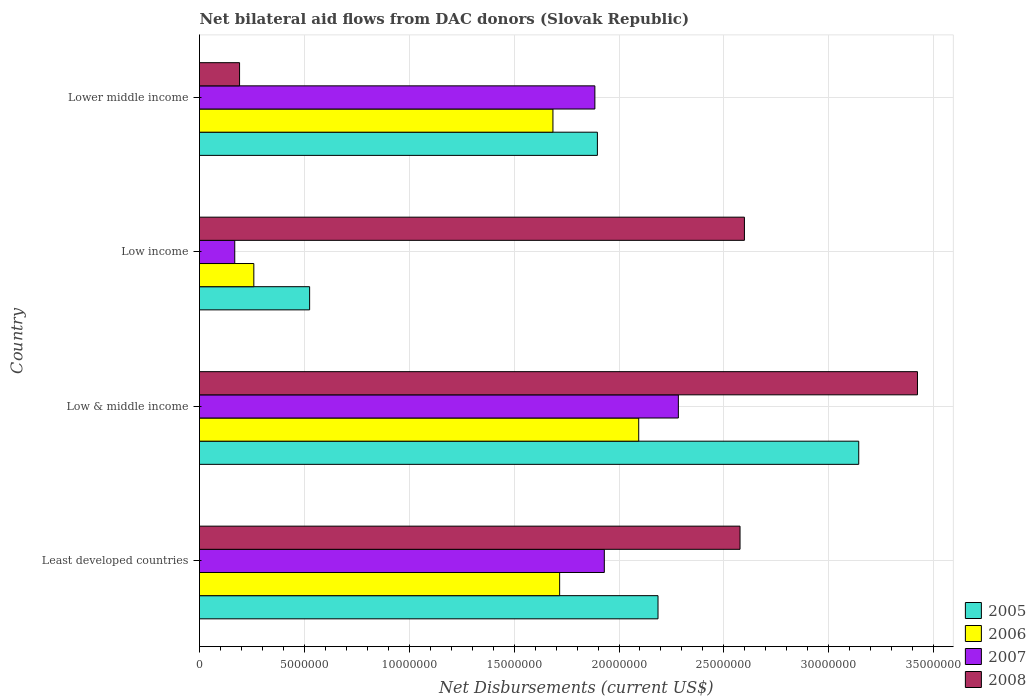How many different coloured bars are there?
Your answer should be very brief. 4. How many groups of bars are there?
Give a very brief answer. 4. Are the number of bars per tick equal to the number of legend labels?
Offer a terse response. Yes. Are the number of bars on each tick of the Y-axis equal?
Provide a short and direct response. Yes. How many bars are there on the 1st tick from the top?
Provide a short and direct response. 4. What is the label of the 1st group of bars from the top?
Provide a short and direct response. Lower middle income. What is the net bilateral aid flows in 2005 in Lower middle income?
Ensure brevity in your answer.  1.90e+07. Across all countries, what is the maximum net bilateral aid flows in 2007?
Your answer should be very brief. 2.28e+07. Across all countries, what is the minimum net bilateral aid flows in 2007?
Ensure brevity in your answer.  1.68e+06. In which country was the net bilateral aid flows in 2006 minimum?
Make the answer very short. Low income. What is the total net bilateral aid flows in 2005 in the graph?
Your response must be concise. 7.75e+07. What is the difference between the net bilateral aid flows in 2007 in Least developed countries and that in Low & middle income?
Ensure brevity in your answer.  -3.53e+06. What is the difference between the net bilateral aid flows in 2007 in Least developed countries and the net bilateral aid flows in 2006 in Low & middle income?
Give a very brief answer. -1.64e+06. What is the average net bilateral aid flows in 2008 per country?
Your response must be concise. 2.20e+07. What is the difference between the net bilateral aid flows in 2008 and net bilateral aid flows in 2005 in Low & middle income?
Your answer should be very brief. 2.80e+06. In how many countries, is the net bilateral aid flows in 2007 greater than 32000000 US$?
Provide a short and direct response. 0. What is the ratio of the net bilateral aid flows in 2005 in Low & middle income to that in Lower middle income?
Give a very brief answer. 1.66. Is the net bilateral aid flows in 2006 in Low income less than that in Lower middle income?
Ensure brevity in your answer.  Yes. What is the difference between the highest and the second highest net bilateral aid flows in 2008?
Offer a terse response. 8.25e+06. What is the difference between the highest and the lowest net bilateral aid flows in 2007?
Offer a very short reply. 2.12e+07. Is it the case that in every country, the sum of the net bilateral aid flows in 2007 and net bilateral aid flows in 2006 is greater than the sum of net bilateral aid flows in 2008 and net bilateral aid flows in 2005?
Your answer should be compact. No. How many bars are there?
Give a very brief answer. 16. How many countries are there in the graph?
Provide a short and direct response. 4. What is the difference between two consecutive major ticks on the X-axis?
Your response must be concise. 5.00e+06. Are the values on the major ticks of X-axis written in scientific E-notation?
Provide a short and direct response. No. How are the legend labels stacked?
Your answer should be compact. Vertical. What is the title of the graph?
Provide a short and direct response. Net bilateral aid flows from DAC donors (Slovak Republic). What is the label or title of the X-axis?
Offer a very short reply. Net Disbursements (current US$). What is the label or title of the Y-axis?
Ensure brevity in your answer.  Country. What is the Net Disbursements (current US$) in 2005 in Least developed countries?
Give a very brief answer. 2.19e+07. What is the Net Disbursements (current US$) in 2006 in Least developed countries?
Give a very brief answer. 1.72e+07. What is the Net Disbursements (current US$) in 2007 in Least developed countries?
Your answer should be compact. 1.93e+07. What is the Net Disbursements (current US$) of 2008 in Least developed countries?
Keep it short and to the point. 2.58e+07. What is the Net Disbursements (current US$) of 2005 in Low & middle income?
Offer a terse response. 3.14e+07. What is the Net Disbursements (current US$) of 2006 in Low & middle income?
Keep it short and to the point. 2.09e+07. What is the Net Disbursements (current US$) in 2007 in Low & middle income?
Offer a terse response. 2.28e+07. What is the Net Disbursements (current US$) of 2008 in Low & middle income?
Offer a very short reply. 3.42e+07. What is the Net Disbursements (current US$) in 2005 in Low income?
Give a very brief answer. 5.25e+06. What is the Net Disbursements (current US$) in 2006 in Low income?
Provide a succinct answer. 2.59e+06. What is the Net Disbursements (current US$) in 2007 in Low income?
Ensure brevity in your answer.  1.68e+06. What is the Net Disbursements (current US$) in 2008 in Low income?
Provide a succinct answer. 2.60e+07. What is the Net Disbursements (current US$) in 2005 in Lower middle income?
Offer a terse response. 1.90e+07. What is the Net Disbursements (current US$) of 2006 in Lower middle income?
Your response must be concise. 1.68e+07. What is the Net Disbursements (current US$) of 2007 in Lower middle income?
Provide a succinct answer. 1.88e+07. What is the Net Disbursements (current US$) of 2008 in Lower middle income?
Give a very brief answer. 1.91e+06. Across all countries, what is the maximum Net Disbursements (current US$) in 2005?
Offer a terse response. 3.14e+07. Across all countries, what is the maximum Net Disbursements (current US$) in 2006?
Make the answer very short. 2.09e+07. Across all countries, what is the maximum Net Disbursements (current US$) in 2007?
Provide a short and direct response. 2.28e+07. Across all countries, what is the maximum Net Disbursements (current US$) in 2008?
Your answer should be compact. 3.42e+07. Across all countries, what is the minimum Net Disbursements (current US$) of 2005?
Give a very brief answer. 5.25e+06. Across all countries, what is the minimum Net Disbursements (current US$) in 2006?
Give a very brief answer. 2.59e+06. Across all countries, what is the minimum Net Disbursements (current US$) of 2007?
Make the answer very short. 1.68e+06. Across all countries, what is the minimum Net Disbursements (current US$) of 2008?
Your answer should be very brief. 1.91e+06. What is the total Net Disbursements (current US$) in 2005 in the graph?
Provide a succinct answer. 7.75e+07. What is the total Net Disbursements (current US$) of 2006 in the graph?
Your response must be concise. 5.76e+07. What is the total Net Disbursements (current US$) of 2007 in the graph?
Offer a terse response. 6.27e+07. What is the total Net Disbursements (current US$) of 2008 in the graph?
Your answer should be very brief. 8.79e+07. What is the difference between the Net Disbursements (current US$) of 2005 in Least developed countries and that in Low & middle income?
Provide a succinct answer. -9.57e+06. What is the difference between the Net Disbursements (current US$) of 2006 in Least developed countries and that in Low & middle income?
Your response must be concise. -3.77e+06. What is the difference between the Net Disbursements (current US$) of 2007 in Least developed countries and that in Low & middle income?
Your response must be concise. -3.53e+06. What is the difference between the Net Disbursements (current US$) in 2008 in Least developed countries and that in Low & middle income?
Offer a terse response. -8.46e+06. What is the difference between the Net Disbursements (current US$) of 2005 in Least developed countries and that in Low income?
Offer a terse response. 1.66e+07. What is the difference between the Net Disbursements (current US$) in 2006 in Least developed countries and that in Low income?
Provide a succinct answer. 1.46e+07. What is the difference between the Net Disbursements (current US$) of 2007 in Least developed countries and that in Low income?
Ensure brevity in your answer.  1.76e+07. What is the difference between the Net Disbursements (current US$) of 2005 in Least developed countries and that in Lower middle income?
Your response must be concise. 2.89e+06. What is the difference between the Net Disbursements (current US$) in 2006 in Least developed countries and that in Lower middle income?
Your answer should be compact. 3.20e+05. What is the difference between the Net Disbursements (current US$) in 2007 in Least developed countries and that in Lower middle income?
Your response must be concise. 4.50e+05. What is the difference between the Net Disbursements (current US$) of 2008 in Least developed countries and that in Lower middle income?
Offer a terse response. 2.39e+07. What is the difference between the Net Disbursements (current US$) of 2005 in Low & middle income and that in Low income?
Keep it short and to the point. 2.62e+07. What is the difference between the Net Disbursements (current US$) of 2006 in Low & middle income and that in Low income?
Provide a succinct answer. 1.84e+07. What is the difference between the Net Disbursements (current US$) of 2007 in Low & middle income and that in Low income?
Your response must be concise. 2.12e+07. What is the difference between the Net Disbursements (current US$) in 2008 in Low & middle income and that in Low income?
Offer a terse response. 8.25e+06. What is the difference between the Net Disbursements (current US$) in 2005 in Low & middle income and that in Lower middle income?
Your response must be concise. 1.25e+07. What is the difference between the Net Disbursements (current US$) in 2006 in Low & middle income and that in Lower middle income?
Offer a terse response. 4.09e+06. What is the difference between the Net Disbursements (current US$) of 2007 in Low & middle income and that in Lower middle income?
Ensure brevity in your answer.  3.98e+06. What is the difference between the Net Disbursements (current US$) in 2008 in Low & middle income and that in Lower middle income?
Provide a succinct answer. 3.23e+07. What is the difference between the Net Disbursements (current US$) of 2005 in Low income and that in Lower middle income?
Make the answer very short. -1.37e+07. What is the difference between the Net Disbursements (current US$) in 2006 in Low income and that in Lower middle income?
Offer a very short reply. -1.43e+07. What is the difference between the Net Disbursements (current US$) in 2007 in Low income and that in Lower middle income?
Give a very brief answer. -1.72e+07. What is the difference between the Net Disbursements (current US$) in 2008 in Low income and that in Lower middle income?
Give a very brief answer. 2.41e+07. What is the difference between the Net Disbursements (current US$) of 2005 in Least developed countries and the Net Disbursements (current US$) of 2006 in Low & middle income?
Offer a terse response. 9.20e+05. What is the difference between the Net Disbursements (current US$) of 2005 in Least developed countries and the Net Disbursements (current US$) of 2007 in Low & middle income?
Make the answer very short. -9.70e+05. What is the difference between the Net Disbursements (current US$) of 2005 in Least developed countries and the Net Disbursements (current US$) of 2008 in Low & middle income?
Offer a terse response. -1.24e+07. What is the difference between the Net Disbursements (current US$) of 2006 in Least developed countries and the Net Disbursements (current US$) of 2007 in Low & middle income?
Your answer should be very brief. -5.66e+06. What is the difference between the Net Disbursements (current US$) of 2006 in Least developed countries and the Net Disbursements (current US$) of 2008 in Low & middle income?
Keep it short and to the point. -1.71e+07. What is the difference between the Net Disbursements (current US$) of 2007 in Least developed countries and the Net Disbursements (current US$) of 2008 in Low & middle income?
Ensure brevity in your answer.  -1.49e+07. What is the difference between the Net Disbursements (current US$) of 2005 in Least developed countries and the Net Disbursements (current US$) of 2006 in Low income?
Your response must be concise. 1.93e+07. What is the difference between the Net Disbursements (current US$) in 2005 in Least developed countries and the Net Disbursements (current US$) in 2007 in Low income?
Your response must be concise. 2.02e+07. What is the difference between the Net Disbursements (current US$) in 2005 in Least developed countries and the Net Disbursements (current US$) in 2008 in Low income?
Your response must be concise. -4.12e+06. What is the difference between the Net Disbursements (current US$) of 2006 in Least developed countries and the Net Disbursements (current US$) of 2007 in Low income?
Give a very brief answer. 1.55e+07. What is the difference between the Net Disbursements (current US$) of 2006 in Least developed countries and the Net Disbursements (current US$) of 2008 in Low income?
Provide a short and direct response. -8.81e+06. What is the difference between the Net Disbursements (current US$) of 2007 in Least developed countries and the Net Disbursements (current US$) of 2008 in Low income?
Keep it short and to the point. -6.68e+06. What is the difference between the Net Disbursements (current US$) in 2005 in Least developed countries and the Net Disbursements (current US$) in 2006 in Lower middle income?
Give a very brief answer. 5.01e+06. What is the difference between the Net Disbursements (current US$) of 2005 in Least developed countries and the Net Disbursements (current US$) of 2007 in Lower middle income?
Ensure brevity in your answer.  3.01e+06. What is the difference between the Net Disbursements (current US$) in 2005 in Least developed countries and the Net Disbursements (current US$) in 2008 in Lower middle income?
Ensure brevity in your answer.  2.00e+07. What is the difference between the Net Disbursements (current US$) in 2006 in Least developed countries and the Net Disbursements (current US$) in 2007 in Lower middle income?
Ensure brevity in your answer.  -1.68e+06. What is the difference between the Net Disbursements (current US$) in 2006 in Least developed countries and the Net Disbursements (current US$) in 2008 in Lower middle income?
Ensure brevity in your answer.  1.53e+07. What is the difference between the Net Disbursements (current US$) of 2007 in Least developed countries and the Net Disbursements (current US$) of 2008 in Lower middle income?
Offer a terse response. 1.74e+07. What is the difference between the Net Disbursements (current US$) of 2005 in Low & middle income and the Net Disbursements (current US$) of 2006 in Low income?
Keep it short and to the point. 2.88e+07. What is the difference between the Net Disbursements (current US$) of 2005 in Low & middle income and the Net Disbursements (current US$) of 2007 in Low income?
Keep it short and to the point. 2.98e+07. What is the difference between the Net Disbursements (current US$) of 2005 in Low & middle income and the Net Disbursements (current US$) of 2008 in Low income?
Make the answer very short. 5.45e+06. What is the difference between the Net Disbursements (current US$) of 2006 in Low & middle income and the Net Disbursements (current US$) of 2007 in Low income?
Offer a terse response. 1.93e+07. What is the difference between the Net Disbursements (current US$) in 2006 in Low & middle income and the Net Disbursements (current US$) in 2008 in Low income?
Your answer should be very brief. -5.04e+06. What is the difference between the Net Disbursements (current US$) of 2007 in Low & middle income and the Net Disbursements (current US$) of 2008 in Low income?
Offer a terse response. -3.15e+06. What is the difference between the Net Disbursements (current US$) of 2005 in Low & middle income and the Net Disbursements (current US$) of 2006 in Lower middle income?
Provide a short and direct response. 1.46e+07. What is the difference between the Net Disbursements (current US$) in 2005 in Low & middle income and the Net Disbursements (current US$) in 2007 in Lower middle income?
Offer a terse response. 1.26e+07. What is the difference between the Net Disbursements (current US$) in 2005 in Low & middle income and the Net Disbursements (current US$) in 2008 in Lower middle income?
Your answer should be very brief. 2.95e+07. What is the difference between the Net Disbursements (current US$) in 2006 in Low & middle income and the Net Disbursements (current US$) in 2007 in Lower middle income?
Your answer should be compact. 2.09e+06. What is the difference between the Net Disbursements (current US$) in 2006 in Low & middle income and the Net Disbursements (current US$) in 2008 in Lower middle income?
Your answer should be very brief. 1.90e+07. What is the difference between the Net Disbursements (current US$) of 2007 in Low & middle income and the Net Disbursements (current US$) of 2008 in Lower middle income?
Offer a very short reply. 2.09e+07. What is the difference between the Net Disbursements (current US$) of 2005 in Low income and the Net Disbursements (current US$) of 2006 in Lower middle income?
Offer a very short reply. -1.16e+07. What is the difference between the Net Disbursements (current US$) of 2005 in Low income and the Net Disbursements (current US$) of 2007 in Lower middle income?
Offer a terse response. -1.36e+07. What is the difference between the Net Disbursements (current US$) of 2005 in Low income and the Net Disbursements (current US$) of 2008 in Lower middle income?
Ensure brevity in your answer.  3.34e+06. What is the difference between the Net Disbursements (current US$) of 2006 in Low income and the Net Disbursements (current US$) of 2007 in Lower middle income?
Give a very brief answer. -1.63e+07. What is the difference between the Net Disbursements (current US$) in 2006 in Low income and the Net Disbursements (current US$) in 2008 in Lower middle income?
Offer a terse response. 6.80e+05. What is the difference between the Net Disbursements (current US$) of 2007 in Low income and the Net Disbursements (current US$) of 2008 in Lower middle income?
Make the answer very short. -2.30e+05. What is the average Net Disbursements (current US$) of 2005 per country?
Give a very brief answer. 1.94e+07. What is the average Net Disbursements (current US$) in 2006 per country?
Your answer should be compact. 1.44e+07. What is the average Net Disbursements (current US$) in 2007 per country?
Make the answer very short. 1.57e+07. What is the average Net Disbursements (current US$) in 2008 per country?
Offer a terse response. 2.20e+07. What is the difference between the Net Disbursements (current US$) in 2005 and Net Disbursements (current US$) in 2006 in Least developed countries?
Provide a short and direct response. 4.69e+06. What is the difference between the Net Disbursements (current US$) in 2005 and Net Disbursements (current US$) in 2007 in Least developed countries?
Ensure brevity in your answer.  2.56e+06. What is the difference between the Net Disbursements (current US$) in 2005 and Net Disbursements (current US$) in 2008 in Least developed countries?
Ensure brevity in your answer.  -3.91e+06. What is the difference between the Net Disbursements (current US$) in 2006 and Net Disbursements (current US$) in 2007 in Least developed countries?
Make the answer very short. -2.13e+06. What is the difference between the Net Disbursements (current US$) in 2006 and Net Disbursements (current US$) in 2008 in Least developed countries?
Provide a succinct answer. -8.60e+06. What is the difference between the Net Disbursements (current US$) in 2007 and Net Disbursements (current US$) in 2008 in Least developed countries?
Your answer should be compact. -6.47e+06. What is the difference between the Net Disbursements (current US$) in 2005 and Net Disbursements (current US$) in 2006 in Low & middle income?
Your response must be concise. 1.05e+07. What is the difference between the Net Disbursements (current US$) in 2005 and Net Disbursements (current US$) in 2007 in Low & middle income?
Your answer should be compact. 8.60e+06. What is the difference between the Net Disbursements (current US$) of 2005 and Net Disbursements (current US$) of 2008 in Low & middle income?
Offer a very short reply. -2.80e+06. What is the difference between the Net Disbursements (current US$) in 2006 and Net Disbursements (current US$) in 2007 in Low & middle income?
Make the answer very short. -1.89e+06. What is the difference between the Net Disbursements (current US$) in 2006 and Net Disbursements (current US$) in 2008 in Low & middle income?
Offer a very short reply. -1.33e+07. What is the difference between the Net Disbursements (current US$) in 2007 and Net Disbursements (current US$) in 2008 in Low & middle income?
Provide a succinct answer. -1.14e+07. What is the difference between the Net Disbursements (current US$) of 2005 and Net Disbursements (current US$) of 2006 in Low income?
Ensure brevity in your answer.  2.66e+06. What is the difference between the Net Disbursements (current US$) in 2005 and Net Disbursements (current US$) in 2007 in Low income?
Ensure brevity in your answer.  3.57e+06. What is the difference between the Net Disbursements (current US$) of 2005 and Net Disbursements (current US$) of 2008 in Low income?
Provide a succinct answer. -2.07e+07. What is the difference between the Net Disbursements (current US$) in 2006 and Net Disbursements (current US$) in 2007 in Low income?
Ensure brevity in your answer.  9.10e+05. What is the difference between the Net Disbursements (current US$) of 2006 and Net Disbursements (current US$) of 2008 in Low income?
Offer a very short reply. -2.34e+07. What is the difference between the Net Disbursements (current US$) of 2007 and Net Disbursements (current US$) of 2008 in Low income?
Your answer should be compact. -2.43e+07. What is the difference between the Net Disbursements (current US$) of 2005 and Net Disbursements (current US$) of 2006 in Lower middle income?
Make the answer very short. 2.12e+06. What is the difference between the Net Disbursements (current US$) of 2005 and Net Disbursements (current US$) of 2007 in Lower middle income?
Provide a succinct answer. 1.20e+05. What is the difference between the Net Disbursements (current US$) of 2005 and Net Disbursements (current US$) of 2008 in Lower middle income?
Give a very brief answer. 1.71e+07. What is the difference between the Net Disbursements (current US$) in 2006 and Net Disbursements (current US$) in 2007 in Lower middle income?
Ensure brevity in your answer.  -2.00e+06. What is the difference between the Net Disbursements (current US$) of 2006 and Net Disbursements (current US$) of 2008 in Lower middle income?
Provide a short and direct response. 1.49e+07. What is the difference between the Net Disbursements (current US$) of 2007 and Net Disbursements (current US$) of 2008 in Lower middle income?
Your answer should be very brief. 1.69e+07. What is the ratio of the Net Disbursements (current US$) in 2005 in Least developed countries to that in Low & middle income?
Provide a succinct answer. 0.7. What is the ratio of the Net Disbursements (current US$) of 2006 in Least developed countries to that in Low & middle income?
Offer a terse response. 0.82. What is the ratio of the Net Disbursements (current US$) of 2007 in Least developed countries to that in Low & middle income?
Your response must be concise. 0.85. What is the ratio of the Net Disbursements (current US$) of 2008 in Least developed countries to that in Low & middle income?
Make the answer very short. 0.75. What is the ratio of the Net Disbursements (current US$) of 2005 in Least developed countries to that in Low income?
Your answer should be compact. 4.16. What is the ratio of the Net Disbursements (current US$) in 2006 in Least developed countries to that in Low income?
Make the answer very short. 6.63. What is the ratio of the Net Disbursements (current US$) in 2007 in Least developed countries to that in Low income?
Your response must be concise. 11.49. What is the ratio of the Net Disbursements (current US$) in 2005 in Least developed countries to that in Lower middle income?
Your answer should be very brief. 1.15. What is the ratio of the Net Disbursements (current US$) of 2007 in Least developed countries to that in Lower middle income?
Offer a terse response. 1.02. What is the ratio of the Net Disbursements (current US$) of 2008 in Least developed countries to that in Lower middle income?
Your answer should be compact. 13.49. What is the ratio of the Net Disbursements (current US$) of 2005 in Low & middle income to that in Low income?
Provide a succinct answer. 5.99. What is the ratio of the Net Disbursements (current US$) in 2006 in Low & middle income to that in Low income?
Your response must be concise. 8.08. What is the ratio of the Net Disbursements (current US$) in 2007 in Low & middle income to that in Low income?
Make the answer very short. 13.59. What is the ratio of the Net Disbursements (current US$) in 2008 in Low & middle income to that in Low income?
Provide a succinct answer. 1.32. What is the ratio of the Net Disbursements (current US$) of 2005 in Low & middle income to that in Lower middle income?
Your response must be concise. 1.66. What is the ratio of the Net Disbursements (current US$) in 2006 in Low & middle income to that in Lower middle income?
Offer a terse response. 1.24. What is the ratio of the Net Disbursements (current US$) in 2007 in Low & middle income to that in Lower middle income?
Your answer should be very brief. 1.21. What is the ratio of the Net Disbursements (current US$) of 2008 in Low & middle income to that in Lower middle income?
Give a very brief answer. 17.92. What is the ratio of the Net Disbursements (current US$) of 2005 in Low income to that in Lower middle income?
Provide a short and direct response. 0.28. What is the ratio of the Net Disbursements (current US$) of 2006 in Low income to that in Lower middle income?
Your response must be concise. 0.15. What is the ratio of the Net Disbursements (current US$) of 2007 in Low income to that in Lower middle income?
Your answer should be very brief. 0.09. What is the ratio of the Net Disbursements (current US$) in 2008 in Low income to that in Lower middle income?
Give a very brief answer. 13.6. What is the difference between the highest and the second highest Net Disbursements (current US$) in 2005?
Make the answer very short. 9.57e+06. What is the difference between the highest and the second highest Net Disbursements (current US$) of 2006?
Make the answer very short. 3.77e+06. What is the difference between the highest and the second highest Net Disbursements (current US$) of 2007?
Provide a short and direct response. 3.53e+06. What is the difference between the highest and the second highest Net Disbursements (current US$) in 2008?
Give a very brief answer. 8.25e+06. What is the difference between the highest and the lowest Net Disbursements (current US$) of 2005?
Keep it short and to the point. 2.62e+07. What is the difference between the highest and the lowest Net Disbursements (current US$) of 2006?
Offer a very short reply. 1.84e+07. What is the difference between the highest and the lowest Net Disbursements (current US$) of 2007?
Keep it short and to the point. 2.12e+07. What is the difference between the highest and the lowest Net Disbursements (current US$) in 2008?
Keep it short and to the point. 3.23e+07. 